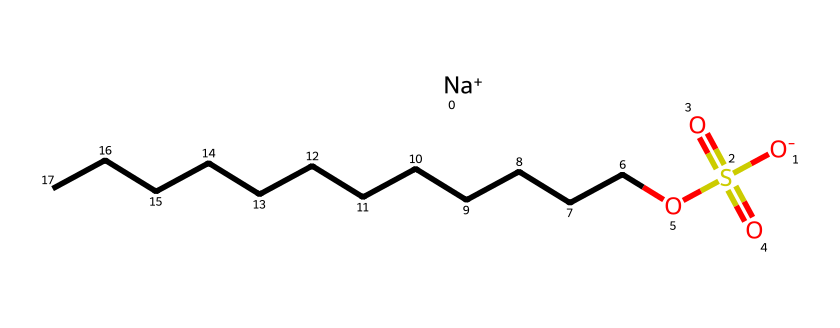What is the name of this chemical? The chemical structure's SMILES representation indicates it is sodium dodecyl sulfate, which is a well-known anionic surfactant. The sodium ion and the dodecyl (12-carbon) chain are key identifiers.
Answer: sodium dodecyl sulfate How many carbon atoms are in the dodecyl chain? The SMILES notation includes CCCCCCCCCCCC, which represents the longest continuous chain of carbon atoms. Counting these gives a total of 12 carbon atoms.
Answer: 12 What type of ion is represented by "Na+" in the structure? The "Na+" in the SMILES indicates that it is a sodium ion, which is positively charged and typically associates with anionic species in surfactants.
Answer: cation What functional groups are present in this chemical? Reviewing the structure reveals a sulfate group (indicated by "S(=O)(=O)O") and an alkyl chain, identifying it as having a polar (sulfate) and a nonpolar (dodecyl) part.
Answer: sulfate group Why is this molecule considered a surfactant? The structure consists of a hydrophobic dodecyl tail and a hydrophilic sulfate head. This amphiphilic nature allows the molecule to reduce surface tension, making it effective in surfactant applications such as emulsification or solubilization.
Answer: amphiphilic What is the charge of the sulfate group in this compound? In the SMILES notation, the sulfate is expressed as "(=O)(=O)O", where the oxygen atom connected to the sodium is negatively charged, resulting in the whole sulfate group being negatively charged.
Answer: negative How does the hydrophobic tail influence the solubility of sodium dodecyl sulfate in water? The long hydrophobic dodecyl tail repels water, enhancing the surfactant's ability to reduce interfacial tension. The hydrophilic sulfate head favors solubility in water, creating a unique interaction that allows amphiphilic behavior.
Answer: reduces solubility 